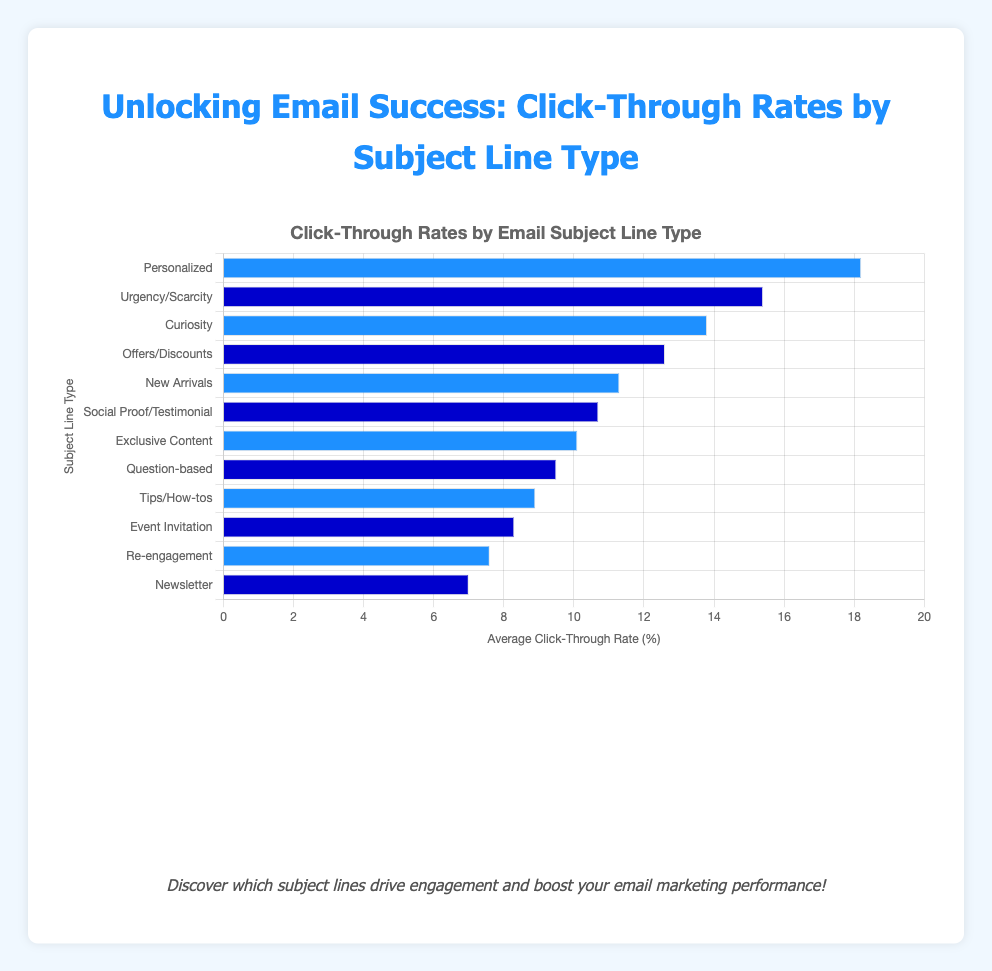Which subject line type has the highest click-through rate? The highest bar represents the "Personalized" subject line type, indicating it has the highest click-through rate.
Answer: Personalized What is the average click-through rate for subject lines that indicate "Question-based"? The "Question-based" subject line type has a bar corresponding to a click-through rate of 9.5%.
Answer: 9.5% How much higher is the click-through rate for "Personalized" subject lines compared to "Curiosity"? The click-through rate for "Personalized" is 18.2%, and for "Curiosity" it is 13.8%. Subtracting these gives 18.2% - 13.8% = 4.4%.
Answer: 4.4% Is the click-through rate for "Offers/Discounts" greater than that for "Event Invitation"? The click-through rate for "Offers/Discounts" is 12.6%, and for "Event Invitation" it is 8.3%. Since 12.6% is greater than 8.3%, the answer is yes.
Answer: Yes What is the sum of the click-through rates for "Exclusive Content" and "Social Proof/Testimonial"? The click-through rate for "Exclusive Content" is 10.1%, and for "Social Proof/Testimonial" it is 10.7%. Adding these gives 10.1% + 10.7% = 20.8%.
Answer: 20.8% How much lower is the click-through rate for "Re-engagement" compared to "Urgency/Scarcity"? The click-through rate for "Re-engagement" is 7.6%, and for "Urgency/Scarcity" it is 15.4%. Subtracting these gives 15.4% - 7.6% = 7.8%.
Answer: 7.8% What is the average click-through rate of the top three performing subject lines? The top three performing subject lines have click-through rates of 18.2%, 15.4%, and 13.8%. Adding these gives 18.2 + 15.4 + 13.8 = 47.4, and dividing by 3 gives 47.4 / 3 = 15.8%.
Answer: 15.8% Which subject line type has the lowest click-through rate? The smallest bar represents the "Newsletter" subject line type, indicating it has the lowest click-through rate.
Answer: Newsletter What is the total click-through rate for all the subject line types combined? Adding all the click-through rates gives 18.2 + 15.4 + 13.8 + 12.6 + 11.3 + 10.7 + 10.1 + 9.5 + 8.9 + 8.3 + 7.6 + 7.0 = 133.4%.
Answer: 133.4% 